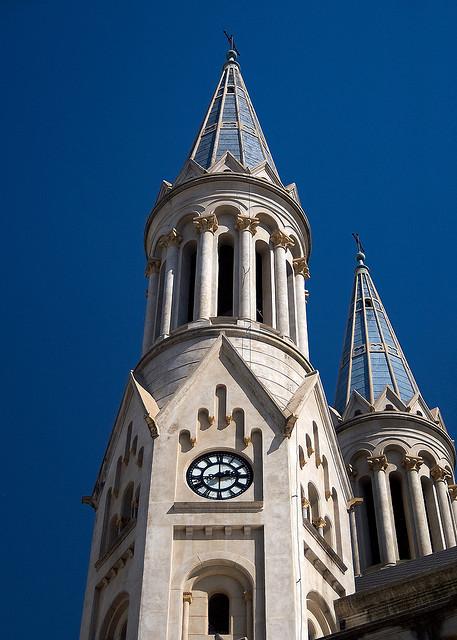What time does the clock say?
Concise answer only. 2:15. What time is it according to the clock?
Answer briefly. 8:15. Are the rooftops conic?
Concise answer only. Yes. Why style of architecture is in the photo?
Give a very brief answer. Gothic. 